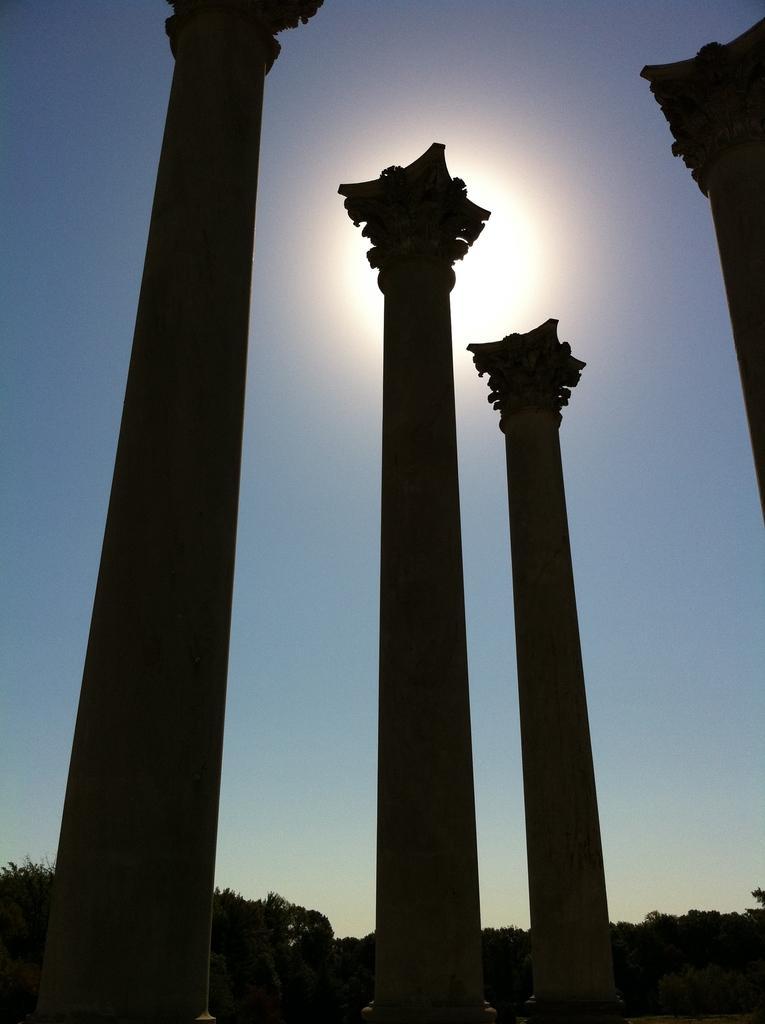Please provide a concise description of this image. In this picture I can see pillars, there are trees, and in the background there is the sky. 